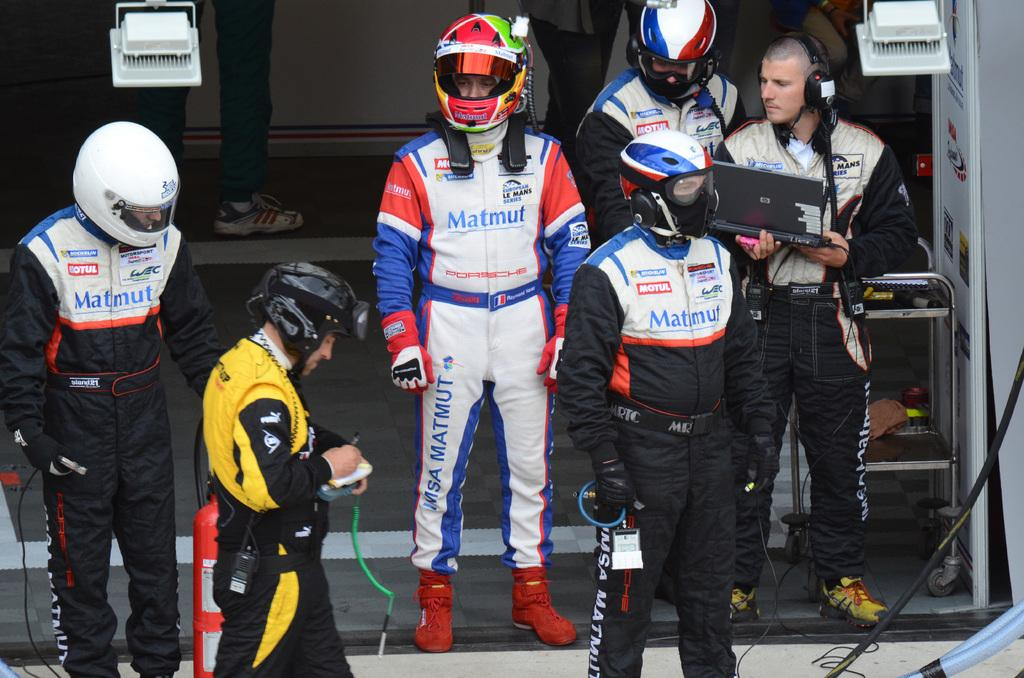What are the persons in the image wearing? The persons in the image are wearing costumes. Where are the persons located in the image? The persons are standing on the ground. What can be seen in the background of the image? There are electric lights, cables, and a fire extinguisher in the background of the image. What type of sock is the governor wearing in the image? There is no governor present in the image, and no one is wearing a sock. 